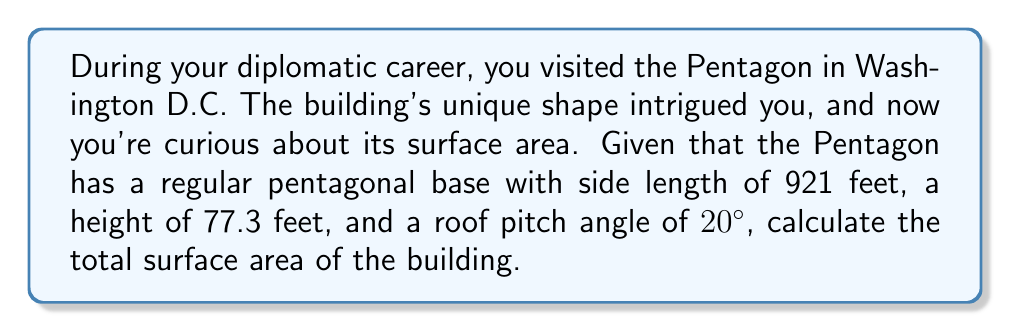Can you solve this math problem? Let's break this down step-by-step:

1. Calculate the area of the pentagonal base:
   The area of a regular pentagon is given by:
   $$A_{base} = \frac{1}{4}\sqrt{25+10\sqrt{5}}s^2$$
   where $s$ is the side length.
   $$A_{base} = \frac{1}{4}\sqrt{25+10\sqrt{5}}(921)^2 = 1,841,844.5 \text{ sq ft}$$

2. Calculate the slant height of the roof:
   Using trigonometry, $\text{slant height} = \frac{\text{half of side length}}{\cos(20°)}$
   $$\text{slant height} = \frac{921/2}{\cos(20°)} = 490.5 \text{ ft}$$

3. Calculate the area of one triangular face of the roof:
   $$A_{roof face} = \frac{1}{2} \times 921 \times 490.5 = 225,875.25 \text{ sq ft}$$

4. Calculate the total roof area (5 triangular faces):
   $$A_{roof} = 5 \times 225,875.25 = 1,129,376.25 \text{ sq ft}$$

5. Calculate the area of the walls:
   Perimeter of base = $5 \times 921 = 4,605 \text{ ft}$
   $$A_{walls} = 4,605 \times 77.3 = 355,966.5 \text{ sq ft}$$

6. Sum up all areas:
   $$A_{total} = A_{base} + A_{roof} + A_{walls}$$
   $$A_{total} = 1,841,844.5 + 1,129,376.25 + 355,966.5 = 3,327,187.25 \text{ sq ft}$$
Answer: $$3,327,187.25 \text{ sq ft}$$ 